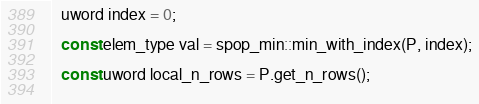Convert code to text. <code><loc_0><loc_0><loc_500><loc_500><_C++_>  uword index = 0;
  
  const elem_type val = spop_min::min_with_index(P, index);
  
  const uword local_n_rows = P.get_n_rows();
  </code> 